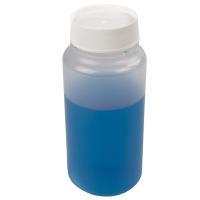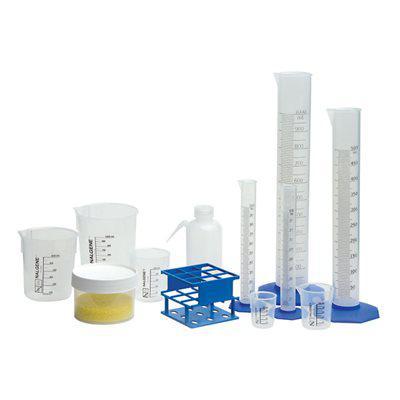The first image is the image on the left, the second image is the image on the right. Examine the images to the left and right. Is the description "The left image shows blue liquid in two containers, and the right image includes multiple capped bottles containing liquid." accurate? Answer yes or no. No. The first image is the image on the left, the second image is the image on the right. Evaluate the accuracy of this statement regarding the images: "There are empty beakers.". Is it true? Answer yes or no. Yes. 